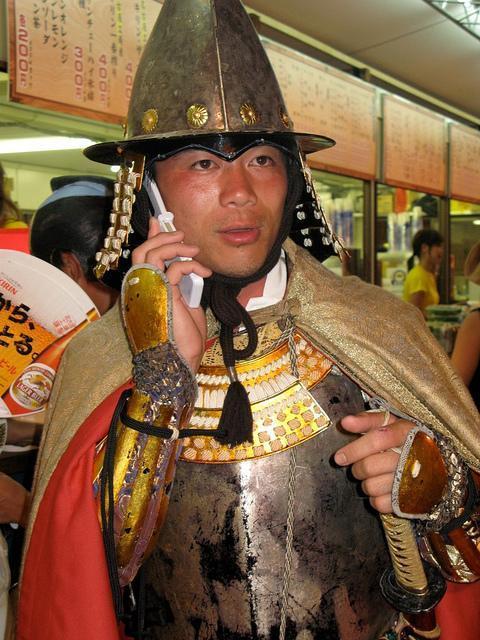How many people are visible?
Give a very brief answer. 3. 